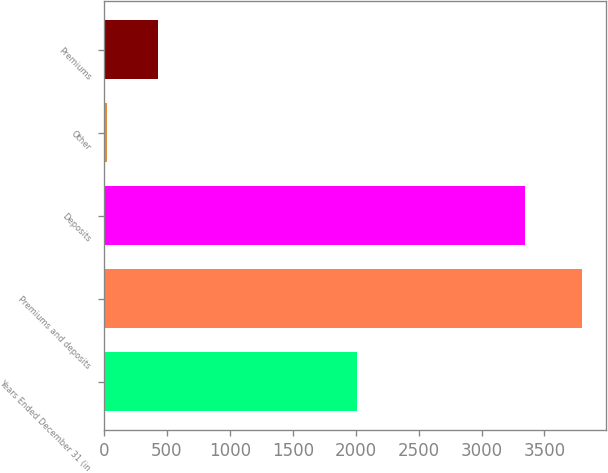Convert chart. <chart><loc_0><loc_0><loc_500><loc_500><bar_chart><fcel>Years Ended December 31 (in<fcel>Premiums and deposits<fcel>Deposits<fcel>Other<fcel>Premiums<nl><fcel>2014<fcel>3797<fcel>3344<fcel>21<fcel>432<nl></chart> 